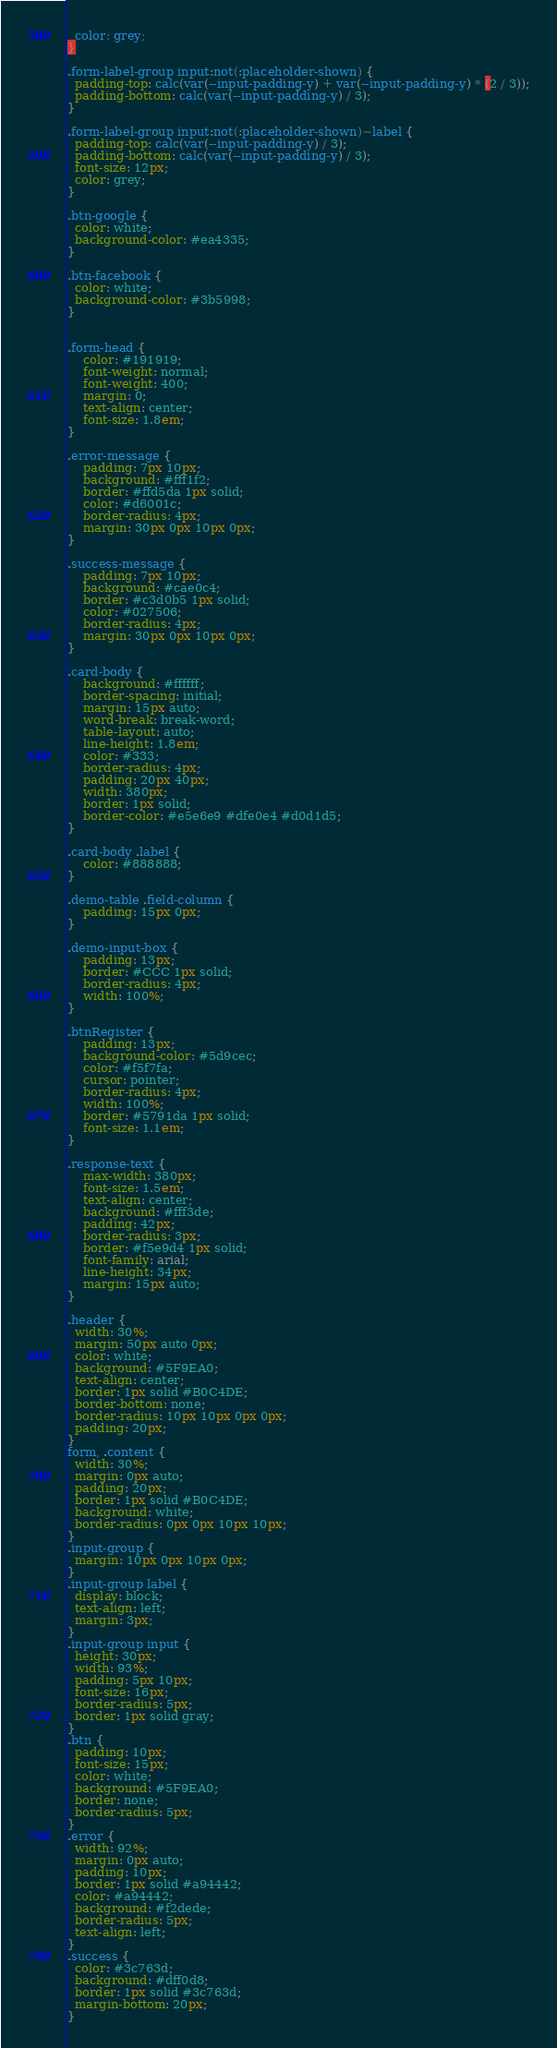Convert code to text. <code><loc_0><loc_0><loc_500><loc_500><_CSS_>  color: grey;
}

.form-label-group input:not(:placeholder-shown) {
  padding-top: calc(var(--input-padding-y) + var(--input-padding-y) * (2 / 3));
  padding-bottom: calc(var(--input-padding-y) / 3);
}

.form-label-group input:not(:placeholder-shown)~label {
  padding-top: calc(var(--input-padding-y) / 3);
  padding-bottom: calc(var(--input-padding-y) / 3);
  font-size: 12px;
  color: grey;
}

.btn-google {
  color: white;
  background-color: #ea4335;
}

.btn-facebook {
  color: white;
  background-color: #3b5998;
}


.form-head {
    color: #191919;
    font-weight: normal;
    font-weight: 400;
    margin: 0;
    text-align: center;
    font-size: 1.8em;
}

.error-message {
    padding: 7px 10px;
    background: #fff1f2;
    border: #ffd5da 1px solid;
    color: #d6001c;
    border-radius: 4px;
    margin: 30px 0px 10px 0px;
}

.success-message {
    padding: 7px 10px;
    background: #cae0c4;
    border: #c3d0b5 1px solid;
    color: #027506;
    border-radius: 4px;
    margin: 30px 0px 10px 0px;
}

.card-body {
    background: #ffffff;
    border-spacing: initial;
    margin: 15px auto;
    word-break: break-word;
    table-layout: auto;
    line-height: 1.8em;
    color: #333;
    border-radius: 4px;
    padding: 20px 40px;
    width: 380px;
    border: 1px solid;
    border-color: #e5e6e9 #dfe0e4 #d0d1d5;
}

.card-body .label {
    color: #888888;
}

.demo-table .field-column {
    padding: 15px 0px;
}

.demo-input-box {
    padding: 13px;
    border: #CCC 1px solid;
    border-radius: 4px;
    width: 100%;
}

.btnRegister {
    padding: 13px;
    background-color: #5d9cec;
    color: #f5f7fa;
    cursor: pointer;
    border-radius: 4px;
    width: 100%;
    border: #5791da 1px solid;
    font-size: 1.1em;
}

.response-text {
    max-width: 380px;
    font-size: 1.5em;
    text-align: center;
    background: #fff3de;
    padding: 42px;
    border-radius: 3px;
    border: #f5e9d4 1px solid;
    font-family: arial;
    line-height: 34px;
    margin: 15px auto;
}

.header {
  width: 30%;
  margin: 50px auto 0px;
  color: white;
  background: #5F9EA0;
  text-align: center;
  border: 1px solid #B0C4DE;
  border-bottom: none;
  border-radius: 10px 10px 0px 0px;
  padding: 20px;
}
form, .content {
  width: 30%;
  margin: 0px auto;
  padding: 20px;
  border: 1px solid #B0C4DE;
  background: white;
  border-radius: 0px 0px 10px 10px;
}
.input-group {
  margin: 10px 0px 10px 0px;
}
.input-group label {
  display: block;
  text-align: left;
  margin: 3px;
}
.input-group input {
  height: 30px;
  width: 93%;
  padding: 5px 10px;
  font-size: 16px;
  border-radius: 5px;
  border: 1px solid gray;
}
.btn {
  padding: 10px;
  font-size: 15px;
  color: white;
  background: #5F9EA0;
  border: none;
  border-radius: 5px;
}
.error {
  width: 92%;
  margin: 0px auto;
  padding: 10px;
  border: 1px solid #a94442;
  color: #a94442;
  background: #f2dede;
  border-radius: 5px;
  text-align: left;
}
.success {
  color: #3c763d;
  background: #dff0d8;
  border: 1px solid #3c763d;
  margin-bottom: 20px;
}
</code> 